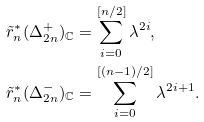<formula> <loc_0><loc_0><loc_500><loc_500>& \tilde { r } _ { n } ^ { * } ( \Delta _ { 2 n } ^ { + } ) _ { \mathbb { C } } = \sum _ { i = 0 } ^ { [ n / 2 ] } \lambda ^ { 2 i } , \\ & \tilde { r } _ { n } ^ { * } ( \Delta _ { 2 n } ^ { - } ) _ { \mathbb { C } } = \sum _ { i = 0 } ^ { [ ( n - 1 ) / 2 ] } \lambda ^ { 2 i + 1 } .</formula> 